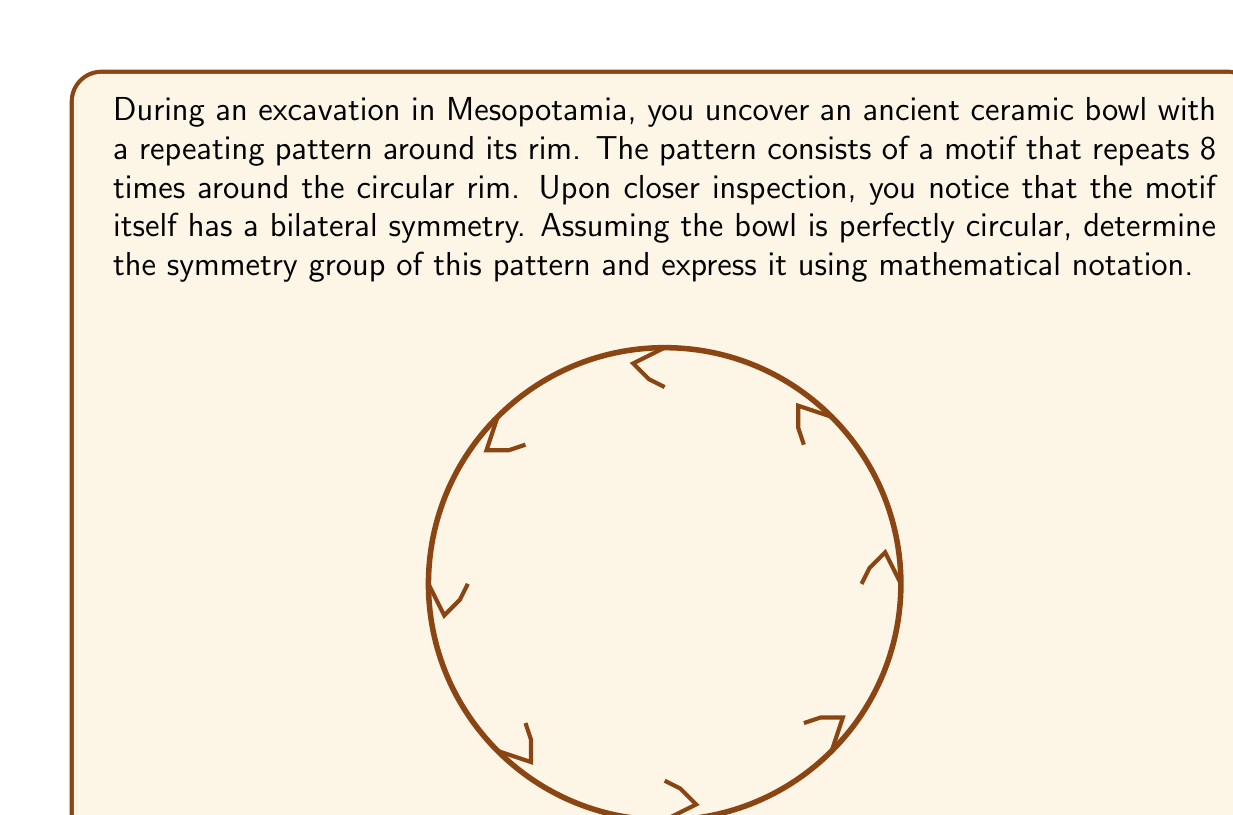Teach me how to tackle this problem. To determine the symmetry group of this pattern, we need to consider both the rotational and reflection symmetries:

1) Rotational symmetry:
   - The pattern repeats 8 times around the rim, so it has 8-fold rotational symmetry.
   - This means it is invariant under rotations of $\frac{360°}{8} = 45°$ and its multiples.
   - These rotations form a cyclic group of order 8, denoted as $C_8$ or $\mathbb{Z}_8$.

2) Reflection symmetry:
   - Each motif has bilateral symmetry, which means there are 8 lines of reflection.
   - These lines of reflection intersect at the center of the bowl and bisect each motif.

3) Combining rotations and reflections:
   - The combination of these symmetries forms a dihedral group of order 16, denoted as $D_8$ or $D_{16}$.
   - The order is 16 because there are 8 rotations (including the identity) and 8 reflections.

4) Group structure:
   - The dihedral group $D_8$ can be expressed as:
     $$ D_8 = \langle r, s \mid r^8 = s^2 = 1, srs = r^{-1} \rangle $$
   where $r$ represents a rotation of 45° and $s$ represents a reflection.

Therefore, the symmetry group of this pattern is the dihedral group $D_8$ (or $D_{16}$).
Answer: $D_8$ (or $D_{16}$) 